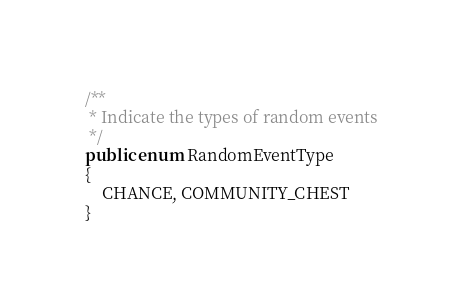<code> <loc_0><loc_0><loc_500><loc_500><_Java_>
/**
 * Indicate the types of random events
 */
public enum RandomEventType
{
	CHANCE, COMMUNITY_CHEST
}
</code> 